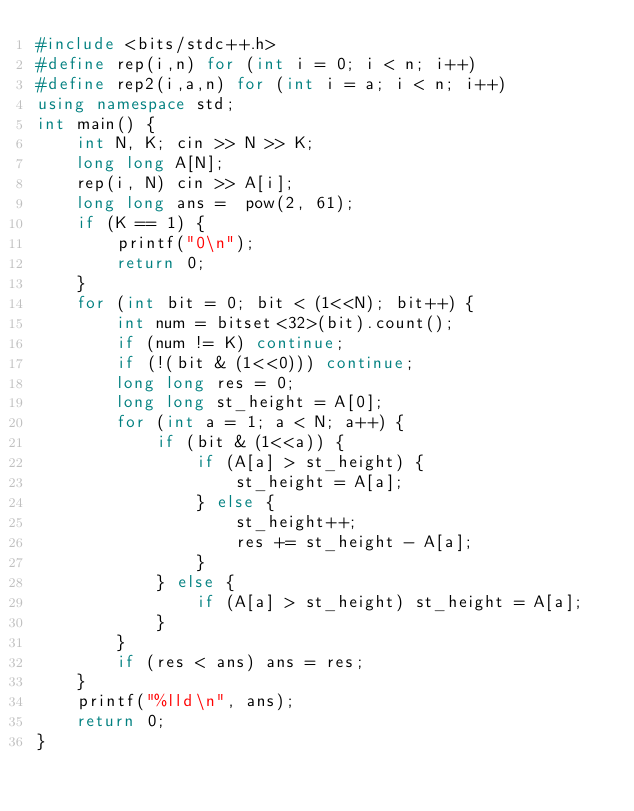Convert code to text. <code><loc_0><loc_0><loc_500><loc_500><_C++_>#include <bits/stdc++.h>
#define rep(i,n) for (int i = 0; i < n; i++)
#define rep2(i,a,n) for (int i = a; i < n; i++)
using namespace std;
int main() {
    int N, K; cin >> N >> K;
    long long A[N];
    rep(i, N) cin >> A[i];
    long long ans =  pow(2, 61);
    if (K == 1) {
        printf("0\n");
        return 0;
    }
    for (int bit = 0; bit < (1<<N); bit++) {
        int num = bitset<32>(bit).count();
        if (num != K) continue;
        if (!(bit & (1<<0))) continue;
        long long res = 0;
        long long st_height = A[0];
        for (int a = 1; a < N; a++) {
            if (bit & (1<<a)) {
                if (A[a] > st_height) {
                    st_height = A[a];
                } else {
                    st_height++;
                    res += st_height - A[a];
                }
            } else {
                if (A[a] > st_height) st_height = A[a];
            }
        }
        if (res < ans) ans = res;
    }
    printf("%lld\n", ans);
    return 0;
}
</code> 